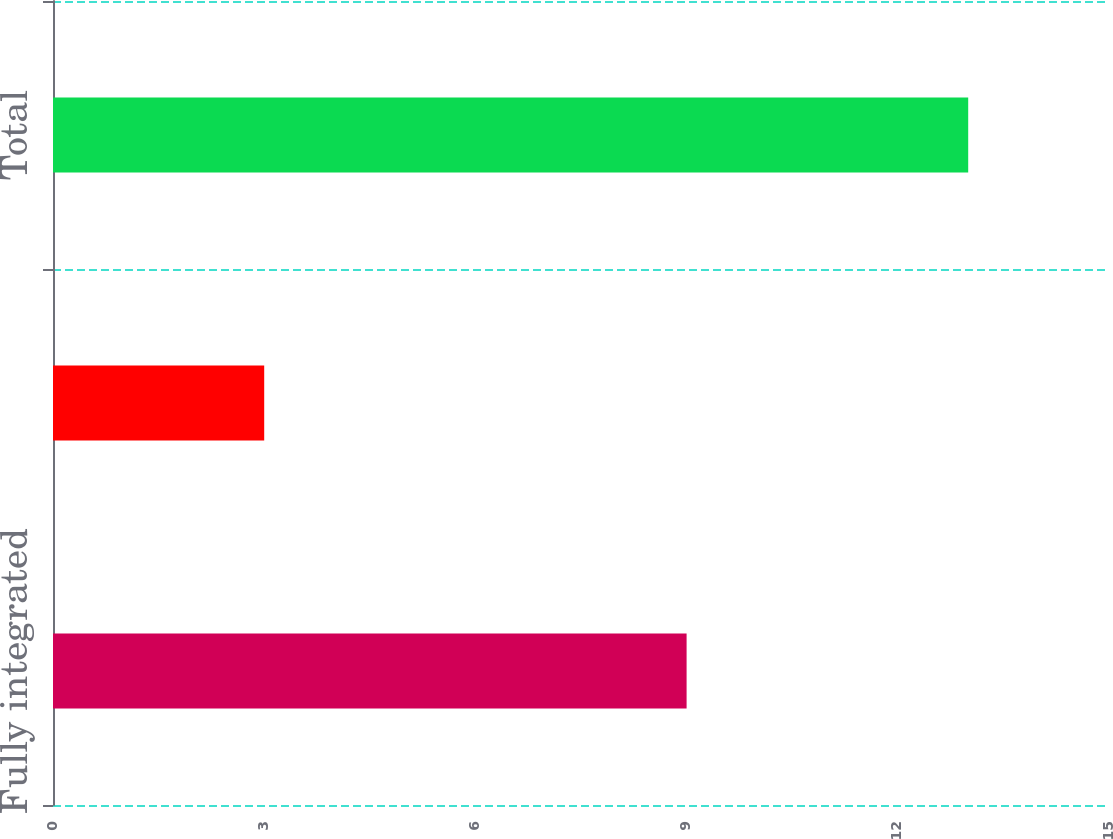Convert chart. <chart><loc_0><loc_0><loc_500><loc_500><bar_chart><fcel>Fully integrated<fcel>Other<fcel>Total<nl><fcel>9<fcel>3<fcel>13<nl></chart> 